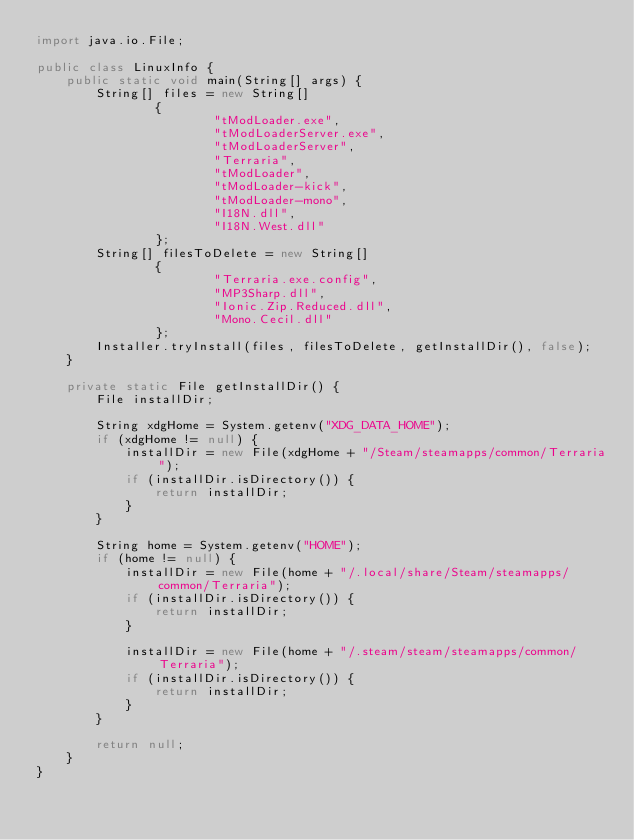Convert code to text. <code><loc_0><loc_0><loc_500><loc_500><_Java_>import java.io.File;

public class LinuxInfo {
    public static void main(String[] args) {
        String[] files = new String[]
                {
                        "tModLoader.exe",
                        "tModLoaderServer.exe",
                        "tModLoaderServer",
                        "Terraria",
                        "tModLoader",
                        "tModLoader-kick",
                        "tModLoader-mono",
                        "I18N.dll",
                        "I18N.West.dll"
                };
        String[] filesToDelete = new String[]
                {
                        "Terraria.exe.config",
                        "MP3Sharp.dll",
                        "Ionic.Zip.Reduced.dll",
                        "Mono.Cecil.dll"
                };
        Installer.tryInstall(files, filesToDelete, getInstallDir(), false);
    }

    private static File getInstallDir() {
        File installDir;

        String xdgHome = System.getenv("XDG_DATA_HOME");
        if (xdgHome != null) {
            installDir = new File(xdgHome + "/Steam/steamapps/common/Terraria");
            if (installDir.isDirectory()) {
                return installDir;
            }
        }

        String home = System.getenv("HOME");
        if (home != null) {
            installDir = new File(home + "/.local/share/Steam/steamapps/common/Terraria");
            if (installDir.isDirectory()) {
                return installDir;
            }

            installDir = new File(home + "/.steam/steam/steamapps/common/Terraria");
            if (installDir.isDirectory()) {
                return installDir;
            }
        }

        return null;
    }
}
</code> 